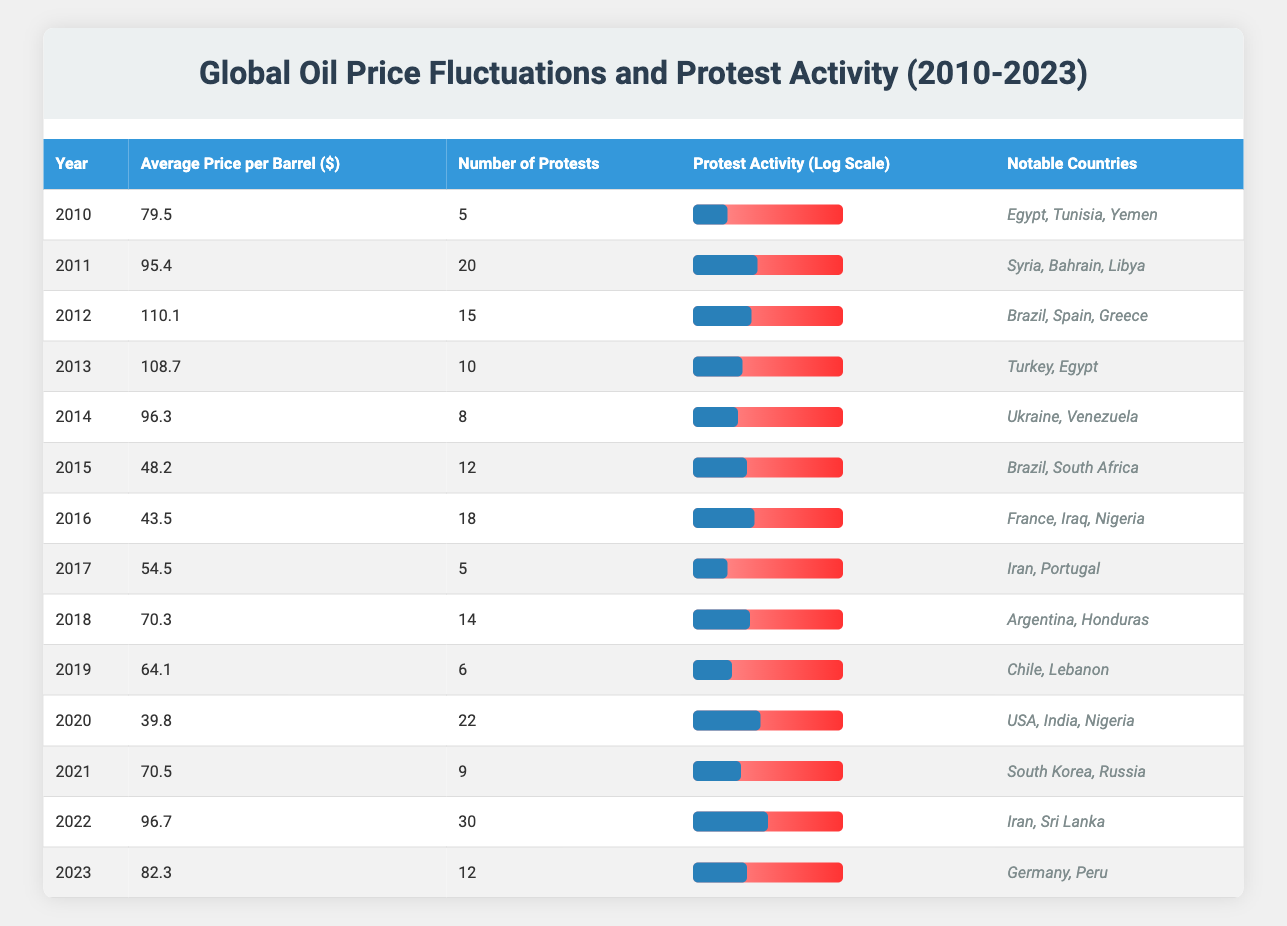What was the average price per barrel in 2015? The table shows that in 2015, the average price per barrel was listed as 48.2.
Answer: 48.2 How many protests occurred in the year with the highest number of protests? By examining the "Number of Protests" column, 2022 has the highest number with 30 protests.
Answer: 30 Were there more protests in 2011 than in 2017? In 2011, there were 20 protests, while in 2017, there were only 5 protests. Therefore, yes, there were more protests in 2011.
Answer: Yes What is the average number of protests from 2010 to 2020? The total number of protests from 2010 to 2020 is calculated as follows: 5 + 20 + 15 + 10 + 8 + 12 + 18 + 5 + 14 + 6 + 22 =  130. There are 11 years in this range, so the average is 130 / 11 = 11.82.
Answer: 11.82 Did the average oil price increase or decrease from 2012 to 2013? In 2012, the average price per barrel was 110.1, and in 2013, it was 108.7. Since 110.1 > 108.7, it indicates a decrease.
Answer: Decrease In which year did the average price per barrel drop to below 50 dollars? Referring to the table, the average price per barrel fell below 50 dollars in 2015, where it is noted as 48.2.
Answer: 2015 What is the total number of protests recorded from 2021 to 2023? For these years: 2021 has 9 protests, 2022 has 30 protests, and 2023 has 12 protests. Summing these gives: 9 + 30 + 12 = 51.
Answer: 51 Is the average price per barrel higher in 2018 than in 2019? In 2018, the average price was 70.3, while in 2019, it was 64.1. Since 70.3 > 64.1, it confirms that the price was indeed higher in 2018.
Answer: Yes Which notable countries appeared in the most protest activity in 2020? The notable countries for protests in 2020 were the USA, India, and Nigeria, marking the year with a significant number of protests at 22.
Answer: USA, India, Nigeria 